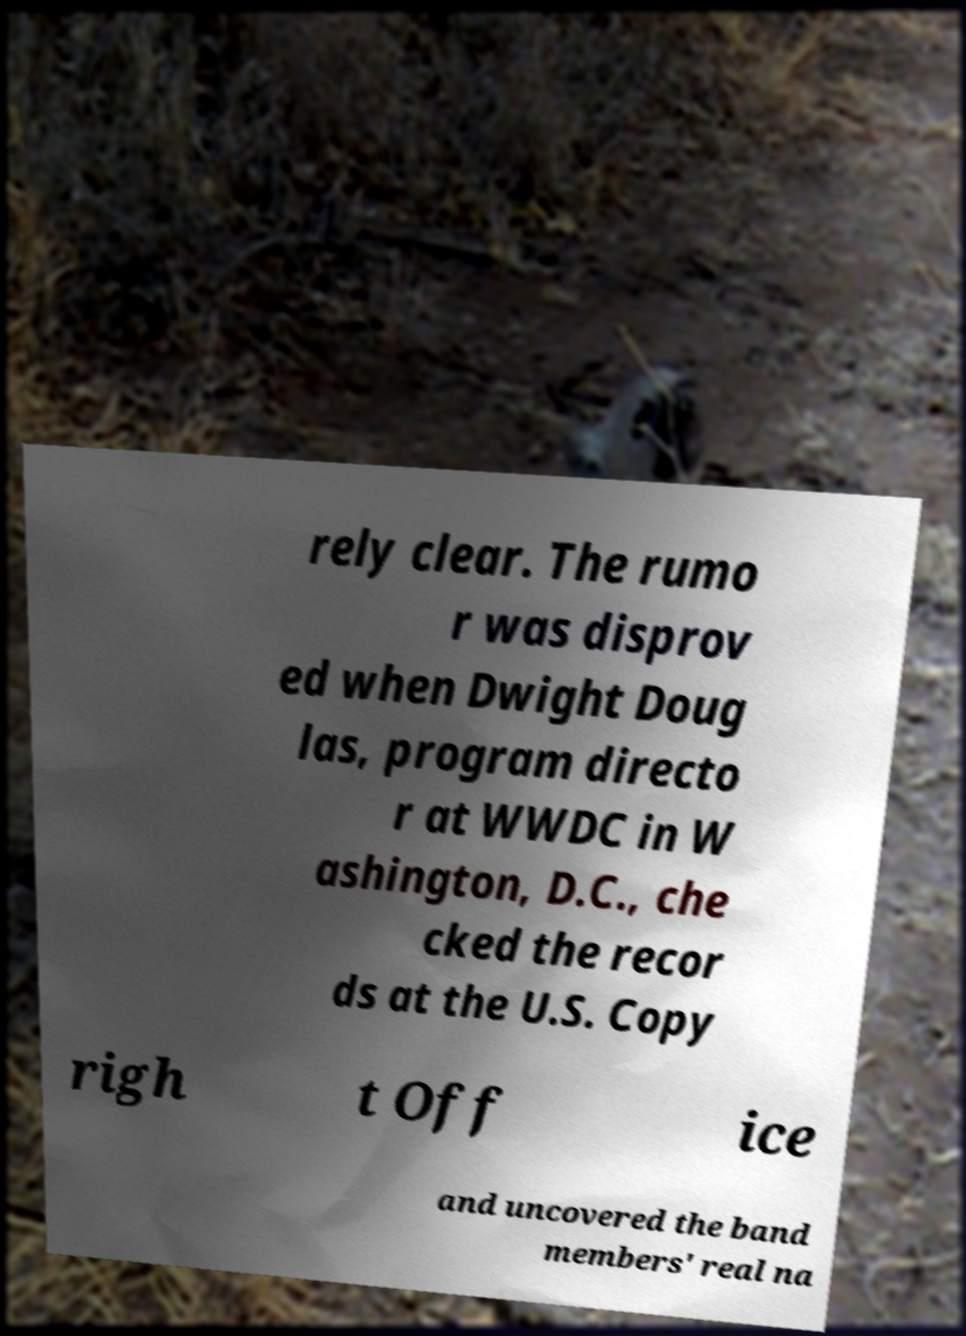For documentation purposes, I need the text within this image transcribed. Could you provide that? rely clear. The rumo r was disprov ed when Dwight Doug las, program directo r at WWDC in W ashington, D.C., che cked the recor ds at the U.S. Copy righ t Off ice and uncovered the band members' real na 